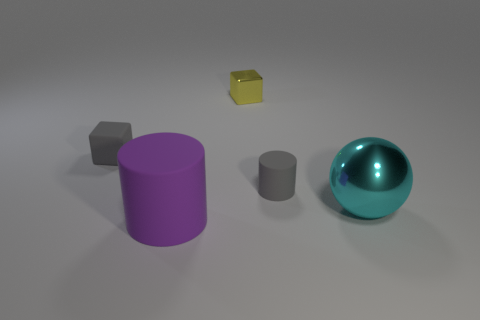Imagine these objects are part of a story. What roles could they play? In a story, the purple cylinder could be seen as a mighty tower standing guard over a mystical realm. The cyan metal sphere might be a magical orb with the power to control water or the sky. The grey and gold cubes could be magical artifacts that heroes must collect, with the grey one being a stone of strength and the gold one being a cube of light. The smallest grey cylinder might be a scroll case holding ancient secrets or a key to unlock a door to another world. 